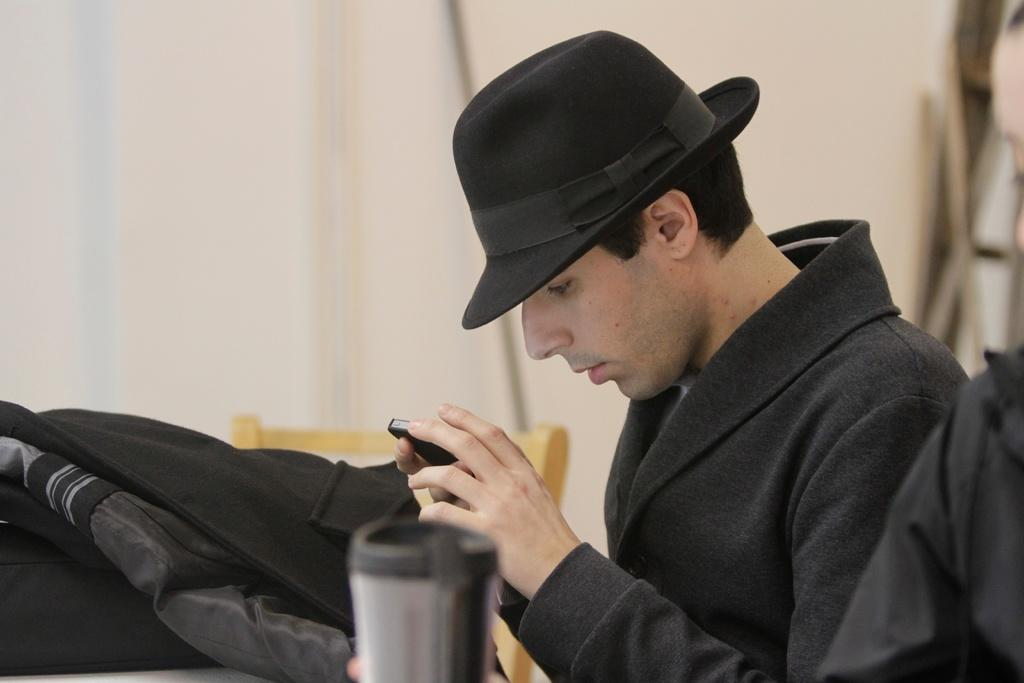Who is present in the image? There is a man in the image. What is the man holding in the image? The man is holding a mobile phone. What accessory is the man wearing on his head? The man is wearing a hat on his head. What can be seen in the background of the image? There is a chair and a curtain in the background of the image. What type of payment is the man making in the image? There is no indication of any payment being made in the image. Can you see the moon in the image? The moon is not visible in the image. 